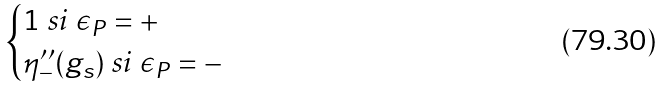Convert formula to latex. <formula><loc_0><loc_0><loc_500><loc_500>\begin{cases} 1 \text { si } \epsilon _ { P } = + \\ \eta ^ { \prime \prime } _ { - } ( g _ { s } ) \text { si } \epsilon _ { P } = - \end{cases}</formula> 